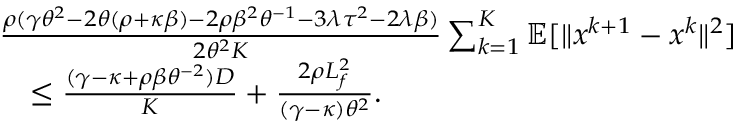Convert formula to latex. <formula><loc_0><loc_0><loc_500><loc_500>\begin{array} { r l } & { \frac { \rho ( \gamma \theta ^ { 2 } - 2 \theta ( \rho + \kappa \beta ) - 2 \rho \beta ^ { 2 } \theta ^ { - 1 } - 3 \lambda \tau ^ { 2 } - 2 \lambda \beta ) } { 2 \theta ^ { 2 } K } \sum _ { k = 1 } ^ { K } \mathbb { E } [ \| x ^ { k + 1 } - x ^ { k } \| ^ { 2 } ] } \\ & { \quad \leq \frac { ( \gamma - \kappa + \rho \beta \theta ^ { - 2 } ) D } { K } + \frac { 2 \rho L _ { f } ^ { 2 } } { ( \gamma - \kappa ) \theta ^ { 2 } } . } \end{array}</formula> 